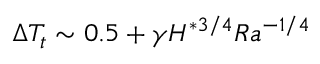<formula> <loc_0><loc_0><loc_500><loc_500>\Delta T _ { t } \sim 0 . 5 + \gamma H ^ { * 3 / 4 } R a ^ { - 1 / 4 }</formula> 